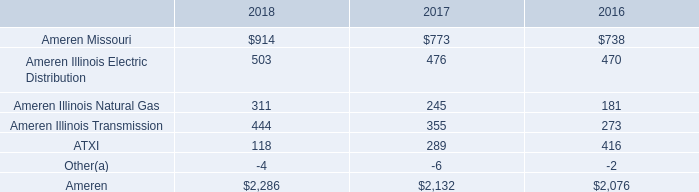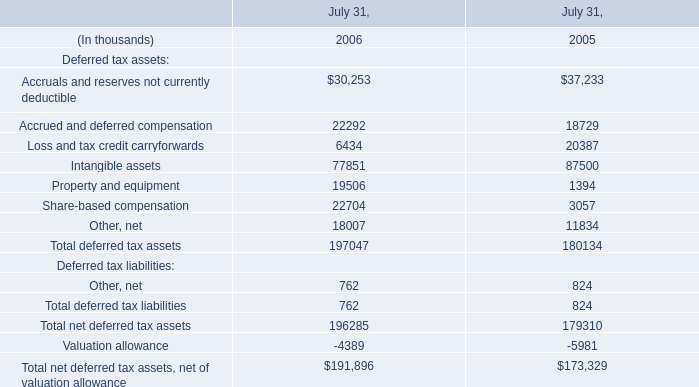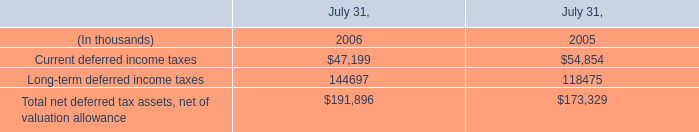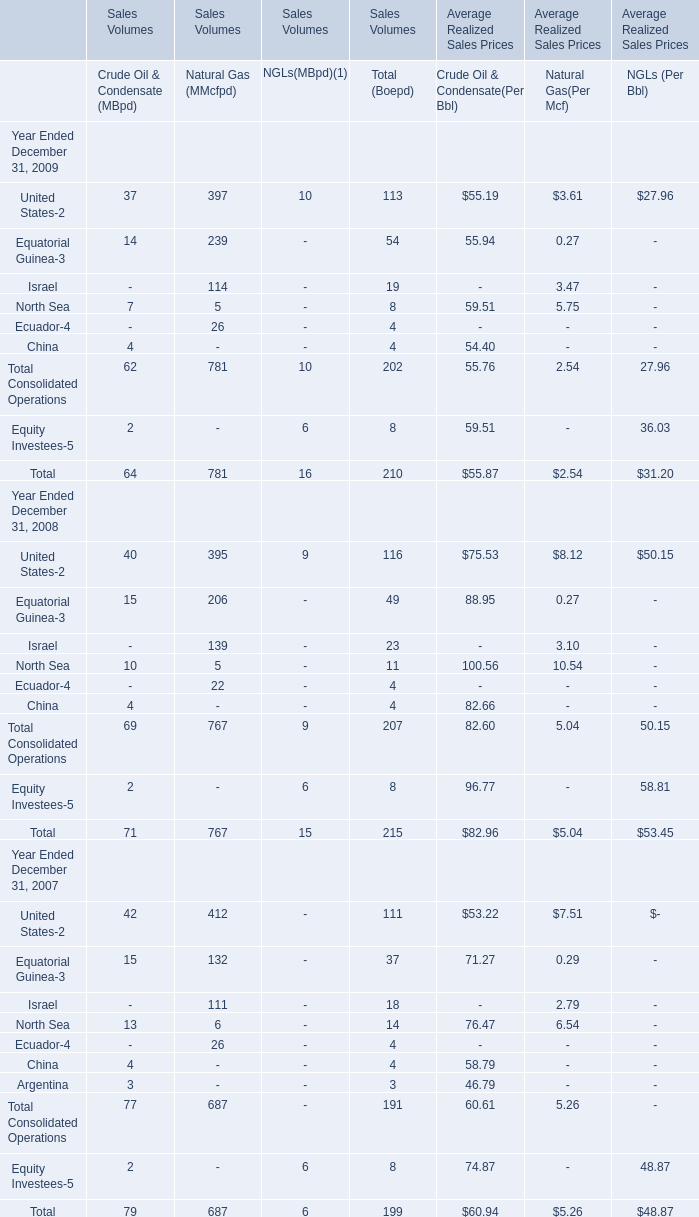What is the ratio of Deferred tax assets:Total deferred tax assets to the Long-term deferred income taxes in 2006? 
Computations: (197047 / 144697)
Answer: 1.36179. 